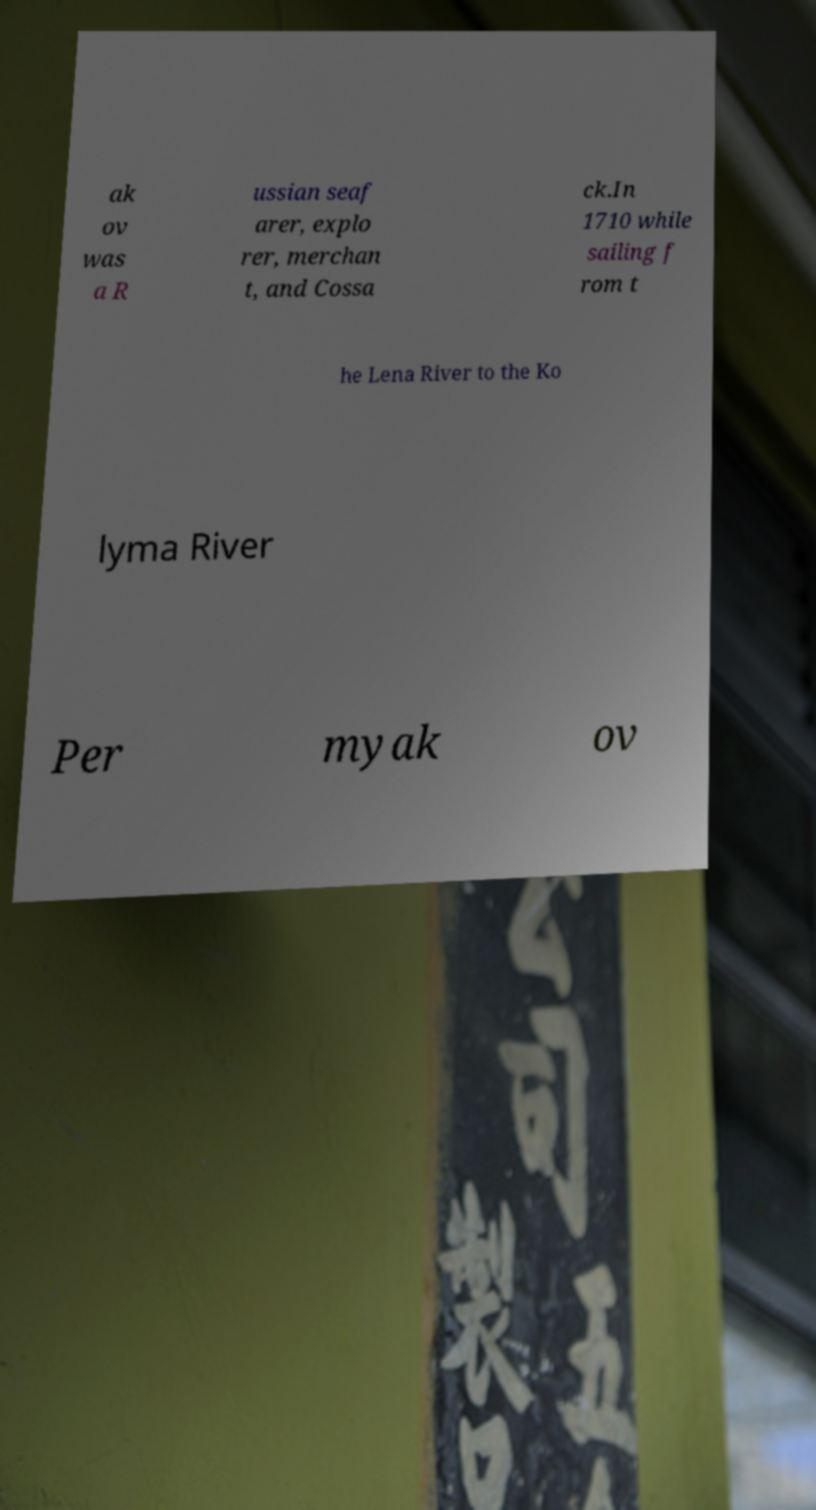Can you read and provide the text displayed in the image?This photo seems to have some interesting text. Can you extract and type it out for me? ak ov was a R ussian seaf arer, explo rer, merchan t, and Cossa ck.In 1710 while sailing f rom t he Lena River to the Ko lyma River Per myak ov 